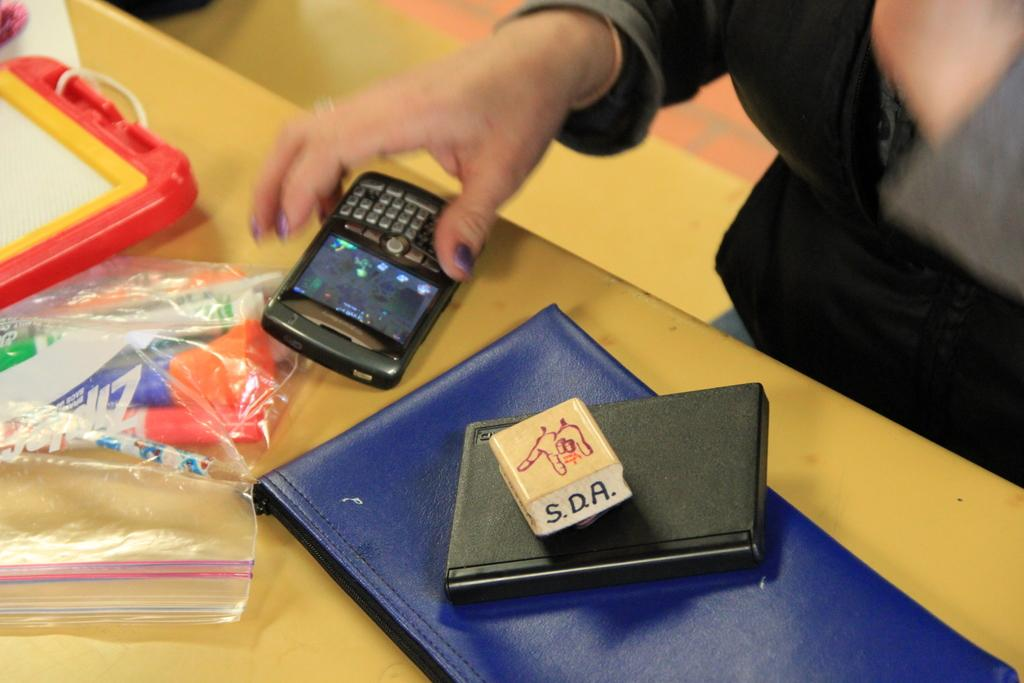<image>
Write a terse but informative summary of the picture. A block of wood has the initials S.D.A on it. 